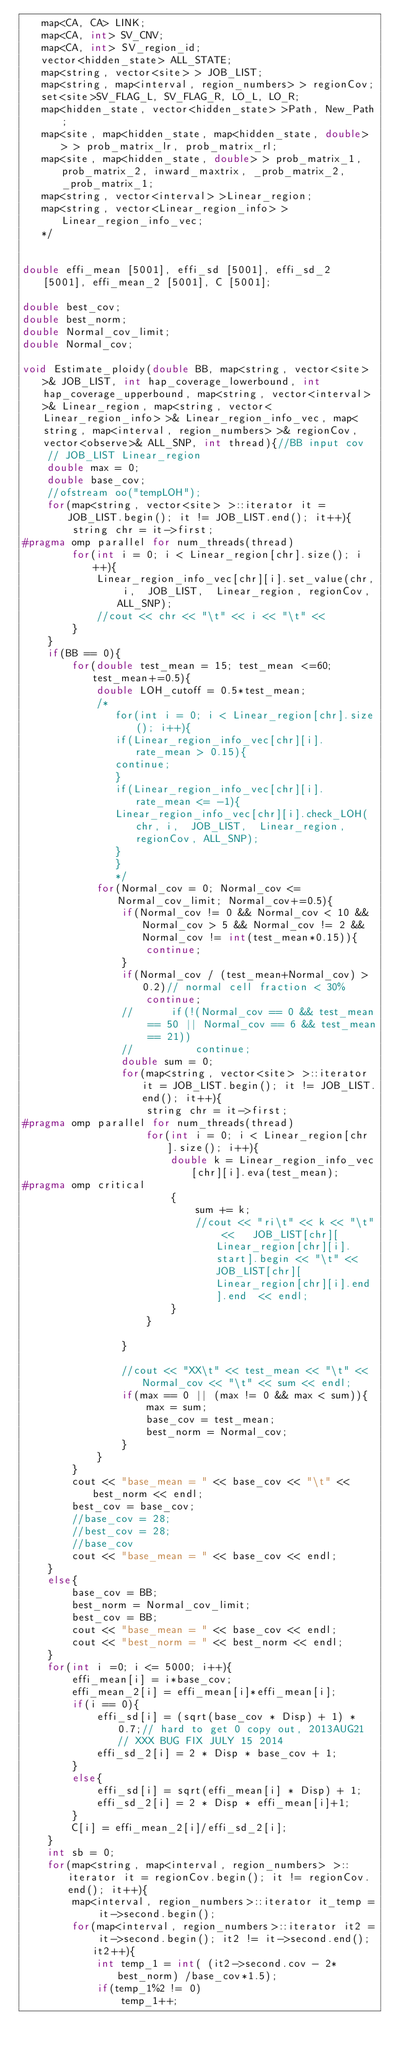Convert code to text. <code><loc_0><loc_0><loc_500><loc_500><_C++_>   map<CA, CA> LINK;
   map<CA, int> SV_CNV;
   map<CA, int> SV_region_id;
   vector<hidden_state> ALL_STATE;
   map<string, vector<site> > JOB_LIST;
   map<string, map<interval, region_numbers> > regionCov;
   set<site>SV_FLAG_L, SV_FLAG_R, LO_L, LO_R;
   map<hidden_state, vector<hidden_state> >Path, New_Path;
   map<site, map<hidden_state, map<hidden_state, double> > > prob_matrix_lr, prob_matrix_rl;
   map<site, map<hidden_state, double> > prob_matrix_1, prob_matrix_2, inward_maxtrix, _prob_matrix_2, _prob_matrix_1;
   map<string, vector<interval> >Linear_region;
   map<string, vector<Linear_region_info> >Linear_region_info_vec;
   */


double effi_mean [5001], effi_sd [5001], effi_sd_2 [5001], effi_mean_2 [5001], C [5001];

double best_cov;
double best_norm;
double Normal_cov_limit;
double Normal_cov;

void Estimate_ploidy(double BB, map<string, vector<site> >& JOB_LIST, int hap_coverage_lowerbound, int hap_coverage_upperbound, map<string, vector<interval> >& Linear_region, map<string, vector<Linear_region_info> >& Linear_region_info_vec, map<string, map<interval, region_numbers> >& regionCov, vector<observe>& ALL_SNP, int thread){//BB input cov
	// JOB_LIST Linear_region
	double max = 0;
	double base_cov;
	//ofstream oo("tempLOH");
	for(map<string, vector<site> >::iterator it = JOB_LIST.begin(); it != JOB_LIST.end(); it++){
		string chr = it->first;
#pragma omp parallel for num_threads(thread)
		for(int i = 0; i < Linear_region[chr].size(); i++){
			Linear_region_info_vec[chr][i].set_value(chr, i,  JOB_LIST,  Linear_region, regionCov, ALL_SNP);
			//cout << chr << "\t" << i << "\t" << 
		}
	}
	if(BB == 0){
		for(double test_mean = 15; test_mean <=60; test_mean+=0.5){
			double LOH_cutoff = 0.5*test_mean;
			/*
			   for(int i = 0; i < Linear_region[chr].size(); i++){
			   if(Linear_region_info_vec[chr][i].rate_mean > 0.15){
			   continue;
			   }
			   if(Linear_region_info_vec[chr][i].rate_mean <= -1){
			   Linear_region_info_vec[chr][i].check_LOH(chr, i,  JOB_LIST,  Linear_region, regionCov, ALL_SNP);
			   }
			   }
			   */
			for(Normal_cov = 0; Normal_cov <= Normal_cov_limit; Normal_cov+=0.5){
				if(Normal_cov != 0 && Normal_cov < 10 && Normal_cov > 5 && Normal_cov != 2 && Normal_cov != int(test_mean*0.15)){
					continue;
				}
				if(Normal_cov / (test_mean+Normal_cov) > 0.2)// normal cell fraction < 30%
					continue;
				//		if(!(Normal_cov == 0 && test_mean == 50 || Normal_cov == 6 && test_mean == 21))
				//			continue;
				double sum = 0;
				for(map<string, vector<site> >::iterator it = JOB_LIST.begin(); it != JOB_LIST.end(); it++){
					string chr = it->first;
#pragma omp parallel for num_threads(thread)
					for(int i = 0; i < Linear_region[chr].size(); i++){
						double k = Linear_region_info_vec[chr][i].eva(test_mean);
#pragma omp critical
						{
							sum += k;
							//cout << "ri\t" << k << "\t" <<   JOB_LIST[chr][Linear_region[chr][i].start].begin << "\t" << JOB_LIST[chr][Linear_region[chr][i].end].end  << endl;
						}
					}

				}

				//cout << "XX\t" << test_mean << "\t" << Normal_cov << "\t" << sum << endl;
				if(max == 0 || (max != 0 && max < sum)){
					max = sum;
					base_cov = test_mean;
					best_norm = Normal_cov;
				}
			}
		}
		cout << "base_mean = " << base_cov << "\t" << best_norm << endl;
		best_cov = base_cov;
		//base_cov = 28;
		//best_cov = 28;
		//base_cov
		cout << "base_mean = " << base_cov << endl;
	}
	else{
		base_cov = BB;
		best_norm = Normal_cov_limit;
		best_cov = BB;
		cout << "base_mean = " << base_cov << endl;
		cout << "best_norm = " << best_norm << endl;
	}
	for(int i =0; i <= 5000; i++){
		effi_mean[i] = i*base_cov;
		effi_mean_2[i] = effi_mean[i]*effi_mean[i];
		if(i == 0){
			effi_sd[i] = (sqrt(base_cov * Disp) + 1) * 0.7;// hard to get 0 copy out, 2013AUG21 // XXX BUG FIX JULY 15 2014 
			effi_sd_2[i] = 2 * Disp * base_cov + 1;
		}
		else{
			effi_sd[i] = sqrt(effi_mean[i] * Disp) + 1;
			effi_sd_2[i] = 2 * Disp * effi_mean[i]+1;
		}
		C[i] = effi_mean_2[i]/effi_sd_2[i];
	}
	int sb = 0;
	for(map<string, map<interval, region_numbers> >::iterator it = regionCov.begin(); it != regionCov.end(); it++){
		map<interval, region_numbers>::iterator it_temp = it->second.begin();
		for(map<interval, region_numbers>::iterator it2 = it->second.begin(); it2 != it->second.end(); it2++){
			int temp_1 = int( (it2->second.cov - 2*best_norm) /base_cov*1.5);
			if(temp_1%2 != 0)
				temp_1++;</code> 